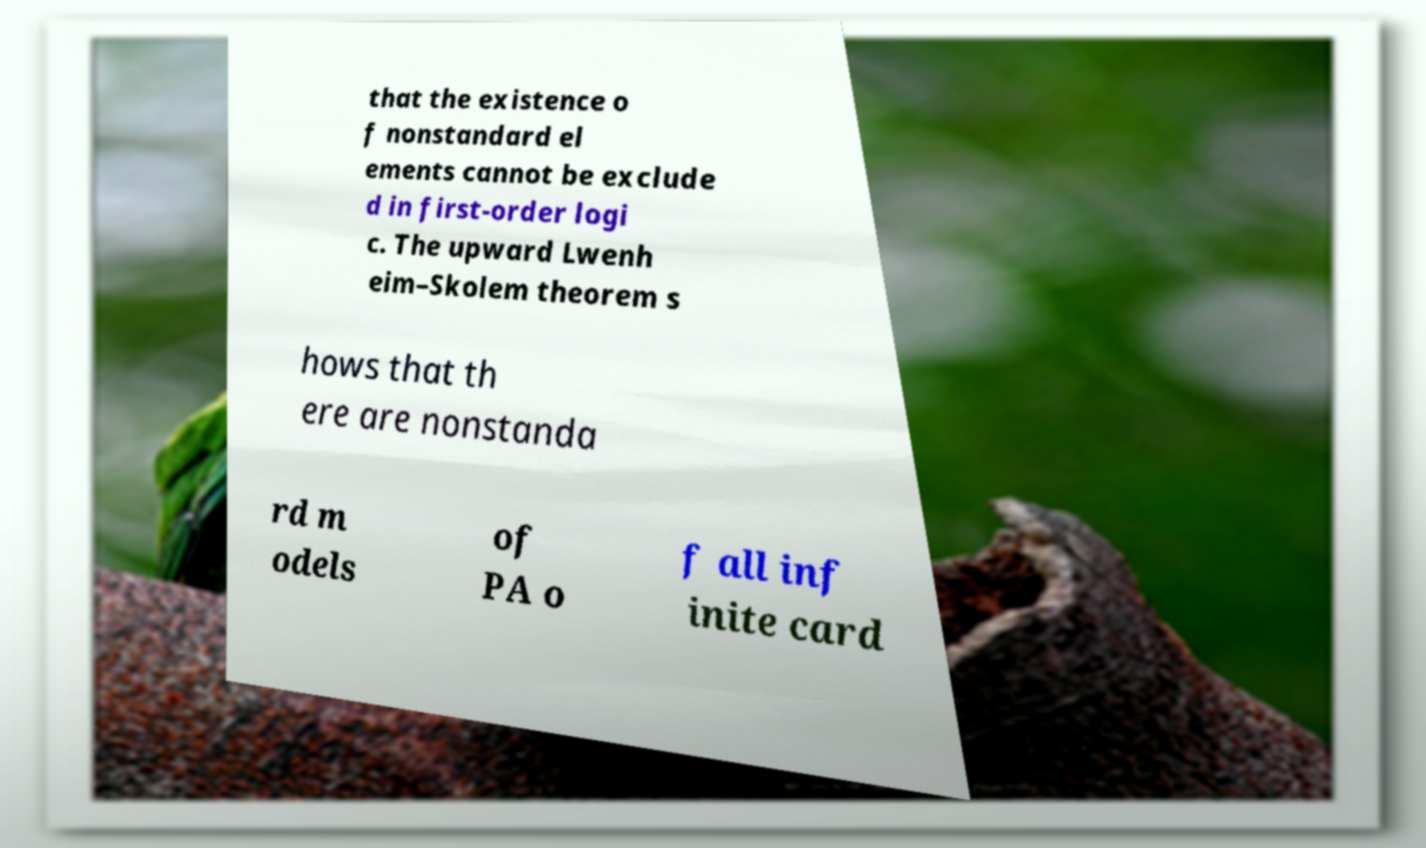Please read and relay the text visible in this image. What does it say? that the existence o f nonstandard el ements cannot be exclude d in first-order logi c. The upward Lwenh eim–Skolem theorem s hows that th ere are nonstanda rd m odels of PA o f all inf inite card 